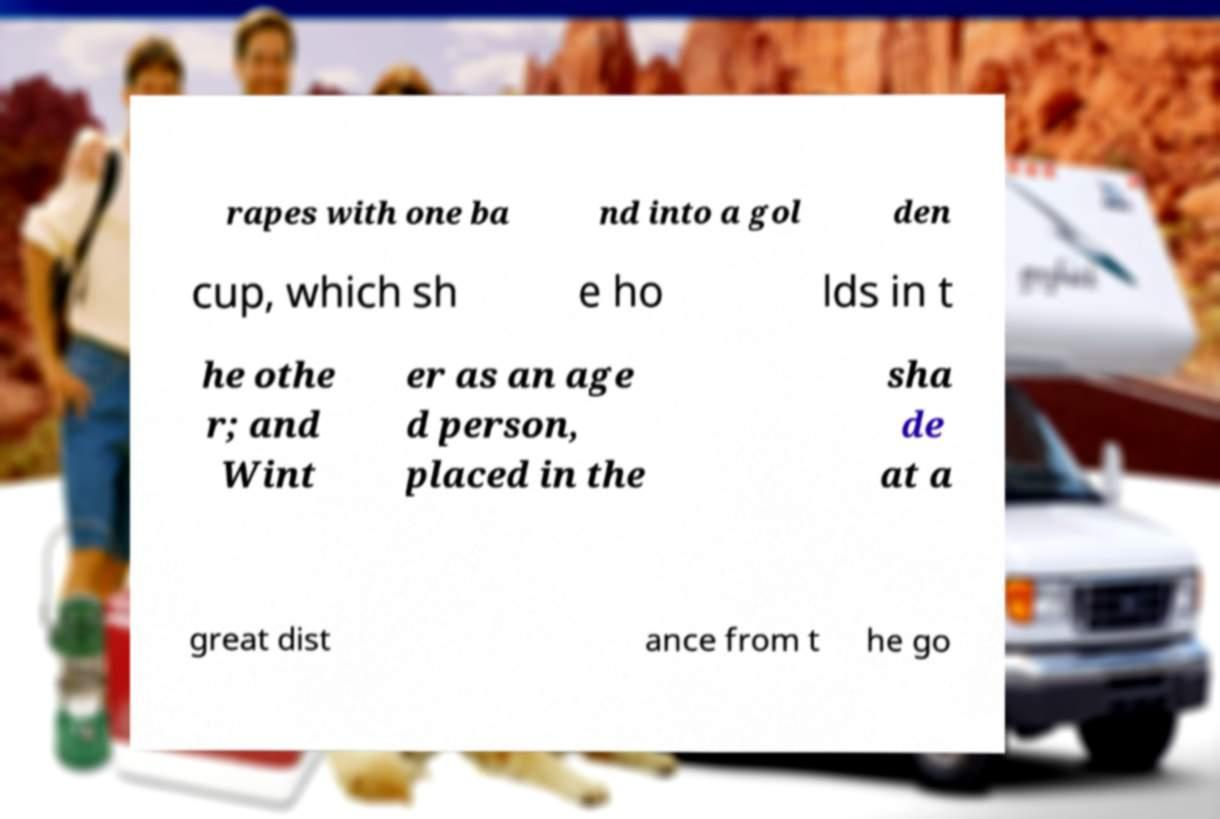Could you extract and type out the text from this image? rapes with one ba nd into a gol den cup, which sh e ho lds in t he othe r; and Wint er as an age d person, placed in the sha de at a great dist ance from t he go 